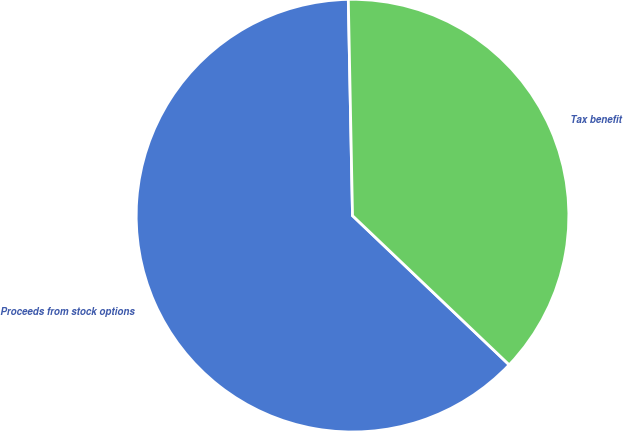Convert chart to OTSL. <chart><loc_0><loc_0><loc_500><loc_500><pie_chart><fcel>Proceeds from stock options<fcel>Tax benefit<nl><fcel>62.58%<fcel>37.42%<nl></chart> 